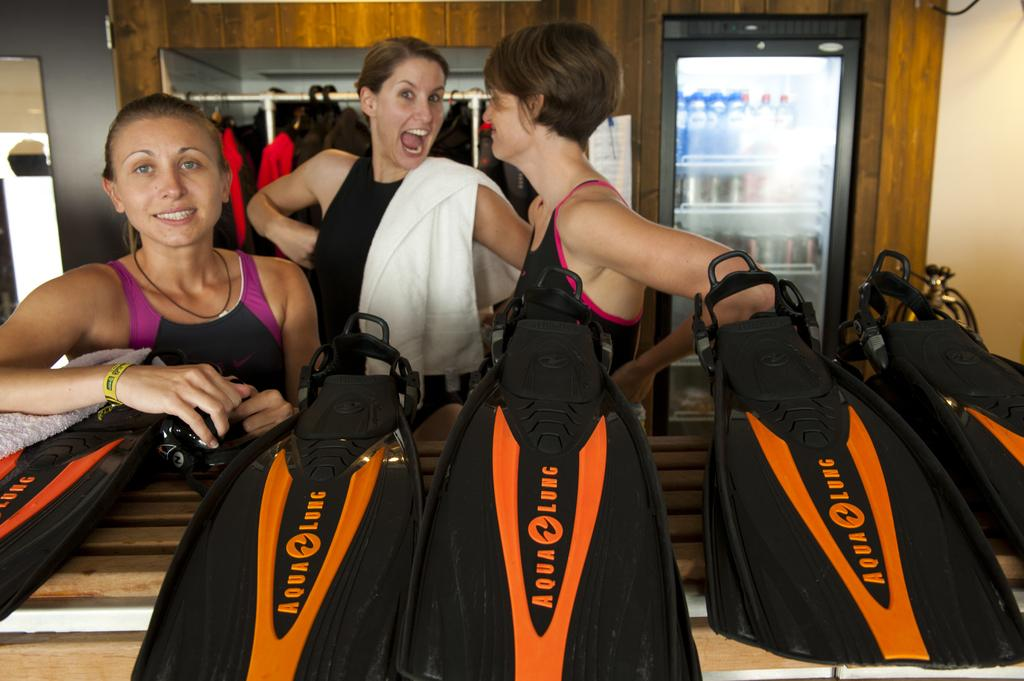What color are the bags in the image? The bags in the image are black. What else can be seen in the image besides the bags? There are clothes and hangers visible in the image. What is the background of the image? There is a wall in the image. What is the object near the wall in the image? There is a vending machine in the image. What is inside the vending machine? The vending machine contains bottles. Can you see a hat on top of the vending machine in the image? There is no hat visible on top of the vending machine in the image. 